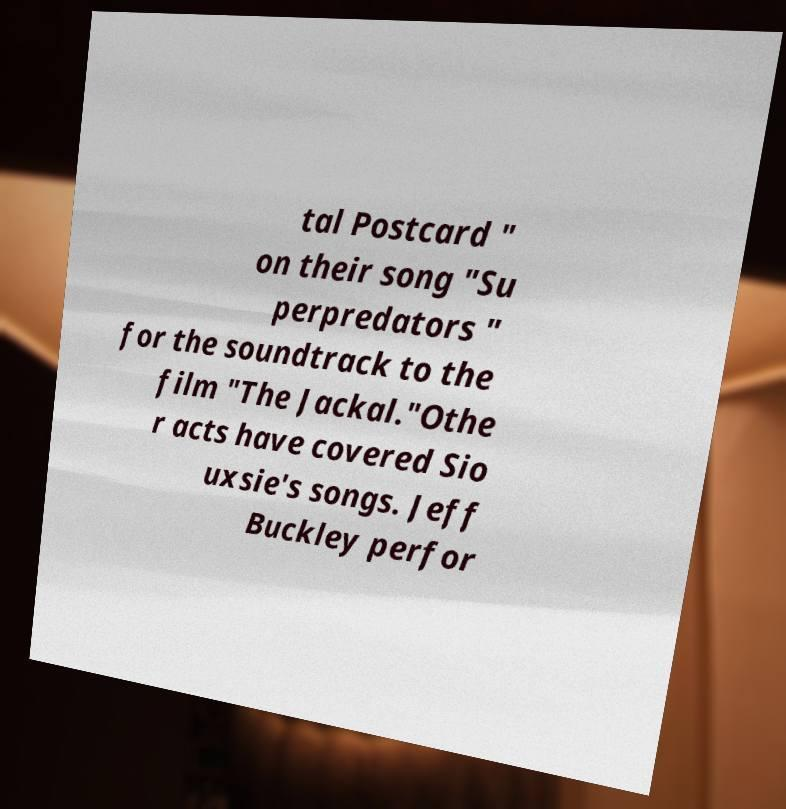Can you read and provide the text displayed in the image?This photo seems to have some interesting text. Can you extract and type it out for me? tal Postcard " on their song "Su perpredators " for the soundtrack to the film "The Jackal."Othe r acts have covered Sio uxsie's songs. Jeff Buckley perfor 